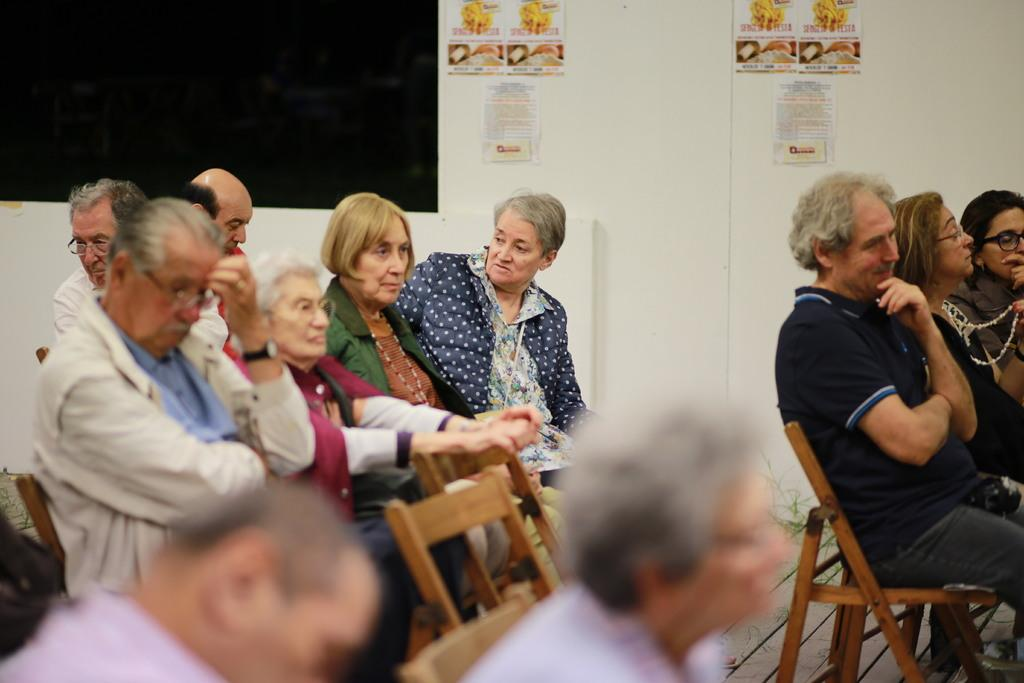How many people are in the image? There is a group of people in the image. What are the people doing in the image? The people are sitting on a bench and appear to be listening to a speech. Which direction are the people facing in the image? The people are facing the right side of the image. What type of flowers can be seen growing on the bench in the image? There are no flowers visible on the bench in the image. How does the heat affect the people sitting on the bench in the image? The provided facts do not mention any heat or temperature, so we cannot determine its effect on the people in the image. 